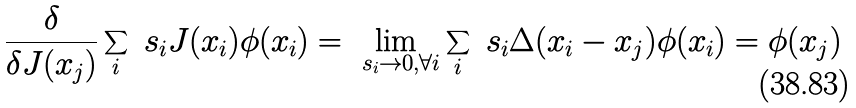<formula> <loc_0><loc_0><loc_500><loc_500>\frac { \delta } { \delta J ( x _ { j } ) } \sum _ { i } \ s _ { i } J ( x _ { i } ) \phi ( x _ { i } ) = \lim _ { \ s _ { i } \rightarrow 0 , \forall i } \sum _ { i } \ s _ { i } \Delta ( x _ { i } - x _ { j } ) \phi ( x _ { i } ) = \phi ( x _ { j } )</formula> 